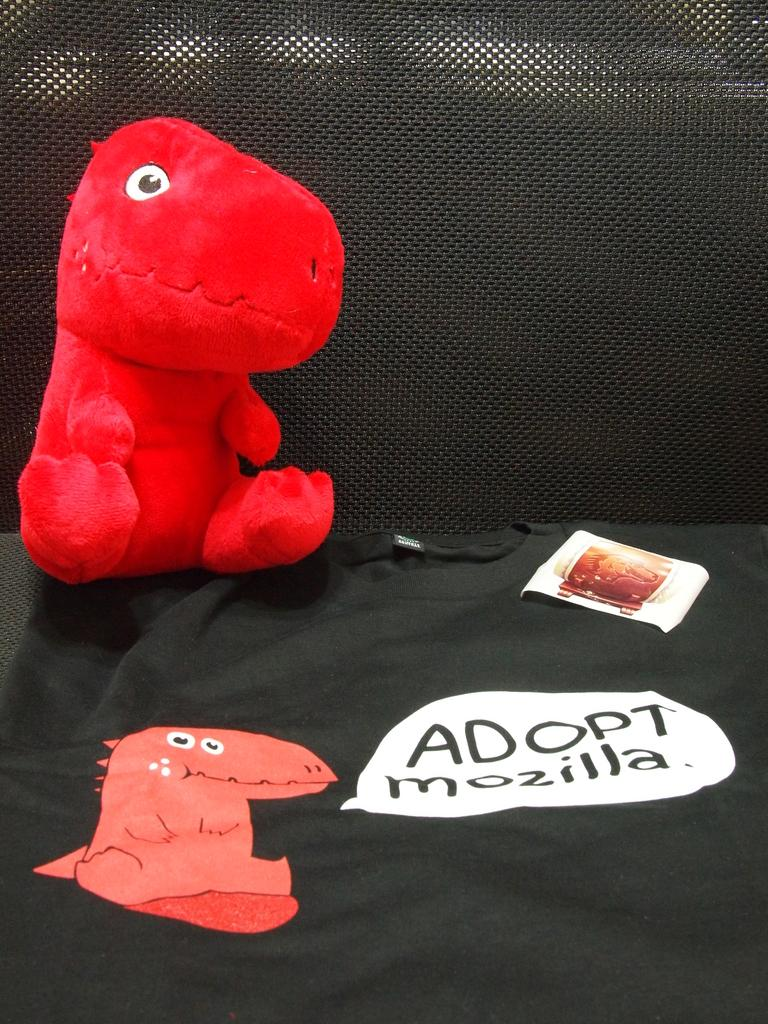What color is the toy that is visible in the image? The toy in the image is red. What type of entertainment is depicted in the image? There is a cartoon in the image. What type of object is present in the image that can be written on? There is a paper in the image. What color is the background of the image? The background of the image is black. How many children are playing with the red toy in the image? There are no children present in the image; it only features a red toy, a cartoon, a paper, and a black background. What type of balls can be seen bouncing in the image? There are no balls present in the image. 